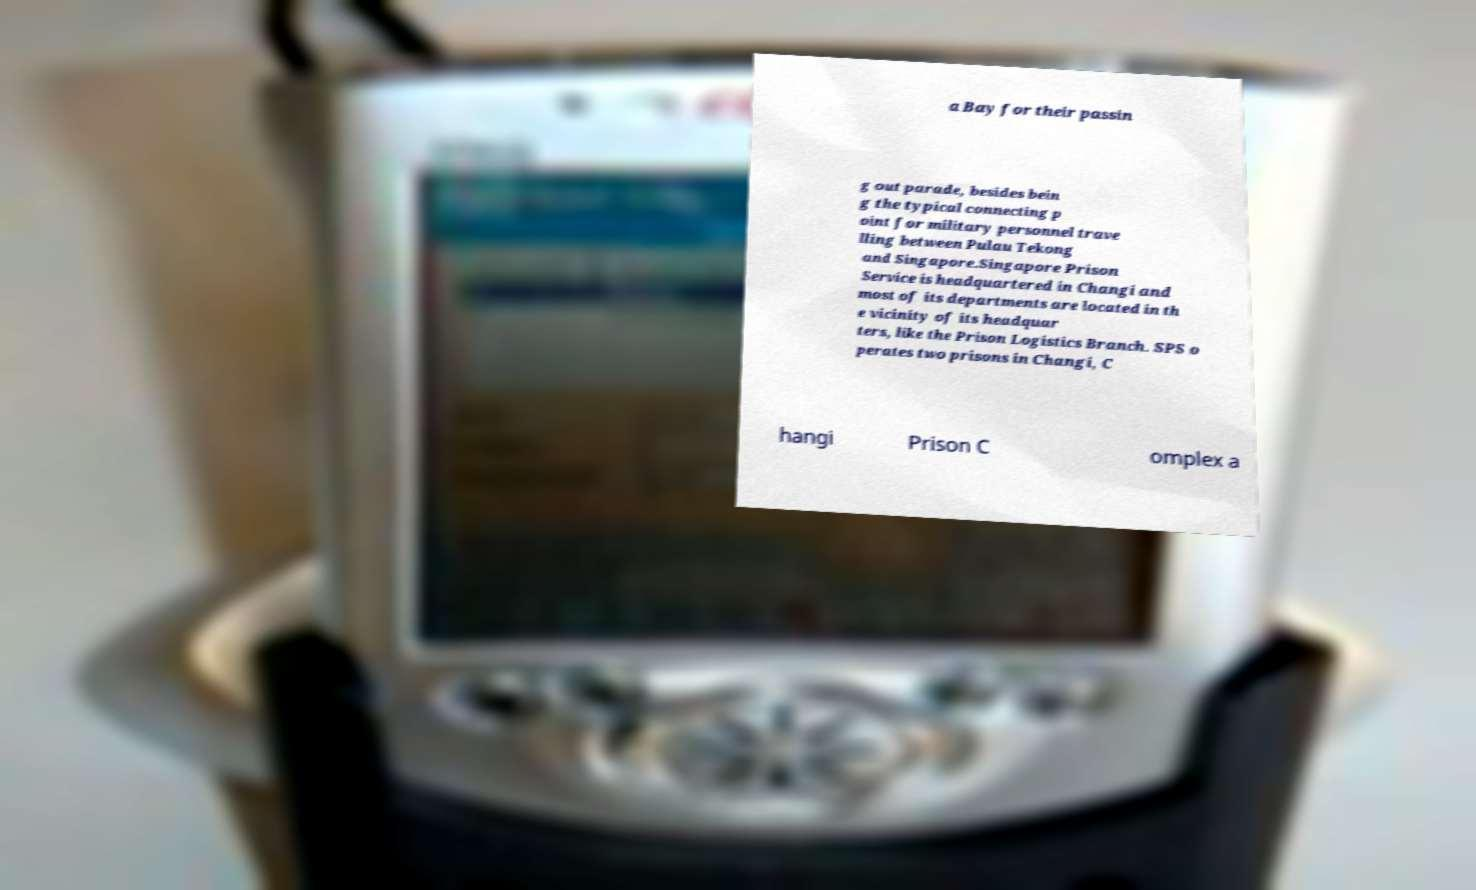Please read and relay the text visible in this image. What does it say? a Bay for their passin g out parade, besides bein g the typical connecting p oint for military personnel trave lling between Pulau Tekong and Singapore.Singapore Prison Service is headquartered in Changi and most of its departments are located in th e vicinity of its headquar ters, like the Prison Logistics Branch. SPS o perates two prisons in Changi, C hangi Prison C omplex a 